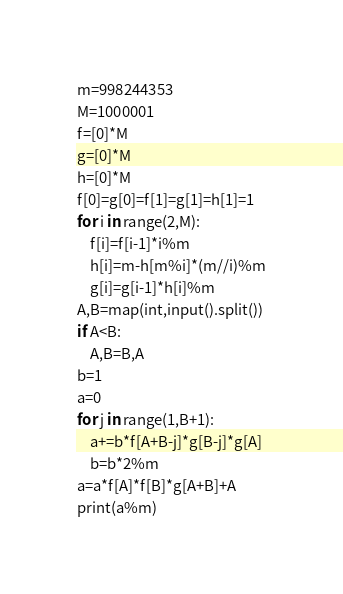<code> <loc_0><loc_0><loc_500><loc_500><_Python_>m=998244353
M=1000001
f=[0]*M
g=[0]*M
h=[0]*M
f[0]=g[0]=f[1]=g[1]=h[1]=1
for i in range(2,M):
	f[i]=f[i-1]*i%m
	h[i]=m-h[m%i]*(m//i)%m
	g[i]=g[i-1]*h[i]%m
A,B=map(int,input().split())
if A<B:
	A,B=B,A
b=1
a=0
for j in range(1,B+1):
	a+=b*f[A+B-j]*g[B-j]*g[A]
	b=b*2%m
a=a*f[A]*f[B]*g[A+B]+A
print(a%m)</code> 